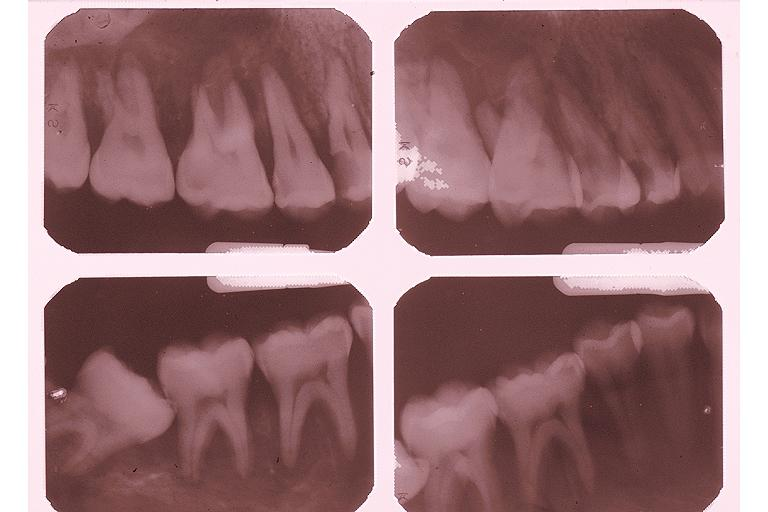does slide show burkits lymphoma?
Answer the question using a single word or phrase. No 